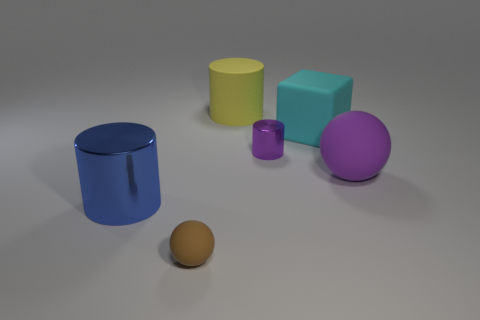Subtract all large blue cylinders. How many cylinders are left? 2 Subtract 3 cylinders. How many cylinders are left? 0 Add 4 red cylinders. How many objects exist? 10 Subtract all balls. How many objects are left? 4 Subtract all blue cylinders. How many cylinders are left? 2 Add 6 purple things. How many purple things are left? 8 Add 3 tiny cyan rubber cylinders. How many tiny cyan rubber cylinders exist? 3 Subtract 1 brown balls. How many objects are left? 5 Subtract all gray cylinders. Subtract all blue blocks. How many cylinders are left? 3 Subtract all blue cubes. How many blue cylinders are left? 1 